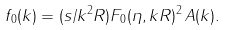Convert formula to latex. <formula><loc_0><loc_0><loc_500><loc_500>f _ { 0 } ( k ) = ( s / k ^ { 2 } R ) F _ { 0 } ( \eta , k R ) ^ { 2 } \, A ( k ) .</formula> 